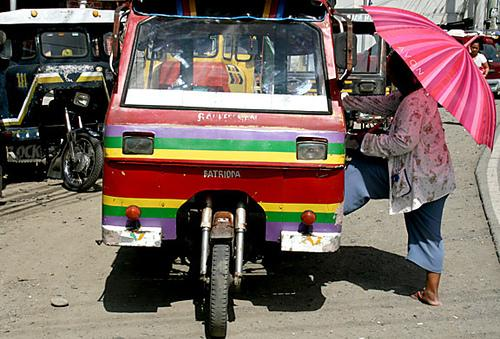What color is at the bottom front of the vehicle in the foreground?

Choices:
A) purple
B) black
C) blue
D) red purple 